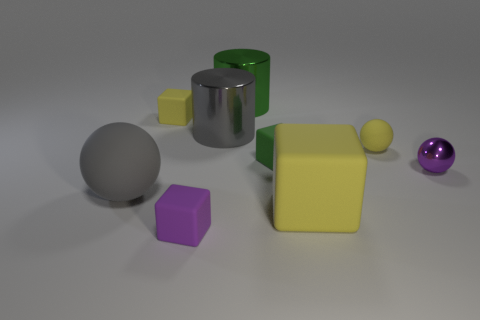What number of shiny things are red cylinders or gray spheres?
Your answer should be compact. 0. What number of metallic things are behind the gray object in front of the tiny purple object on the right side of the tiny yellow matte ball?
Your answer should be very brief. 3. Do the rubber ball left of the purple matte thing and the yellow rubber object to the left of the gray metallic cylinder have the same size?
Give a very brief answer. No. What material is the other tiny object that is the same shape as the purple metal thing?
Your response must be concise. Rubber. How many large things are metal cylinders or yellow metal cylinders?
Keep it short and to the point. 2. What is the material of the large block?
Provide a short and direct response. Rubber. What material is the thing that is behind the purple ball and on the right side of the big yellow rubber thing?
Ensure brevity in your answer.  Rubber. There is a shiny sphere; does it have the same color as the ball left of the tiny yellow ball?
Provide a succinct answer. No. What material is the gray cylinder that is the same size as the gray rubber ball?
Your answer should be compact. Metal. Are there any small yellow cubes that have the same material as the large yellow thing?
Offer a very short reply. Yes. 